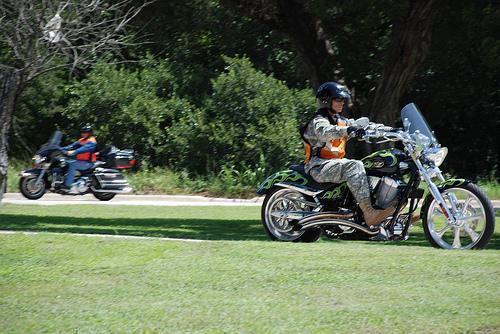How many people are wearing orange safety vests?
Give a very brief answer. 2. How many hands are the drivers driving with?
Give a very brief answer. 2. 